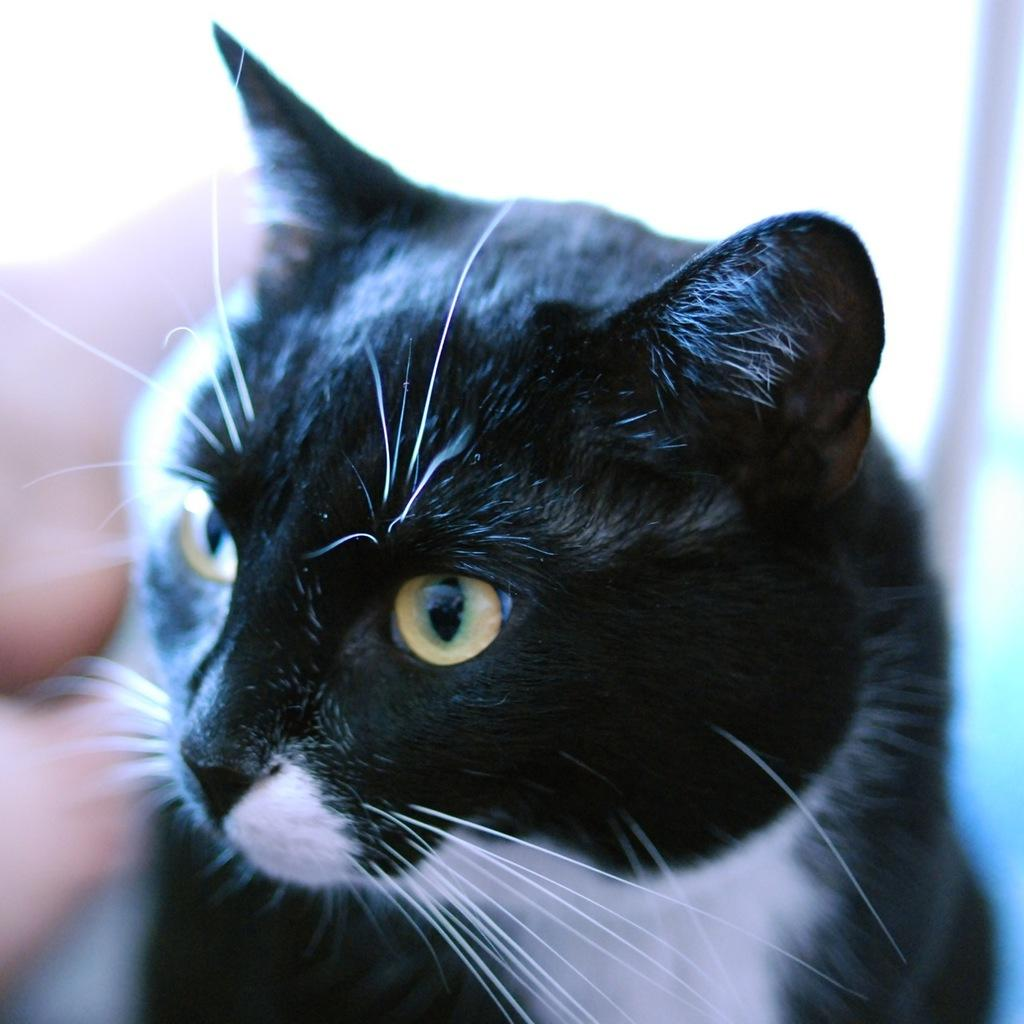What type of animal is in the picture? There is a black color cat in the picture. Where is the cat located in the image? The cat is in the middle of the picture. Can you describe the background of the image? The background of the image is blurred. What type of hammer is the cat using in the image? There is no hammer present in the image; the cat is simply sitting in the middle of the picture. 